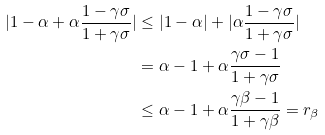Convert formula to latex. <formula><loc_0><loc_0><loc_500><loc_500>| 1 - \alpha + \alpha \frac { 1 - \gamma \sigma } { 1 + \gamma \sigma } | & \leq | 1 - \alpha | + | \alpha \frac { 1 - \gamma \sigma } { 1 + \gamma \sigma } | \\ & = \alpha - 1 + \alpha \frac { \gamma \sigma - 1 } { 1 + \gamma \sigma } \\ & \leq \alpha - 1 + \alpha \frac { \gamma \beta - 1 } { 1 + \gamma \beta } = r _ { \beta }</formula> 